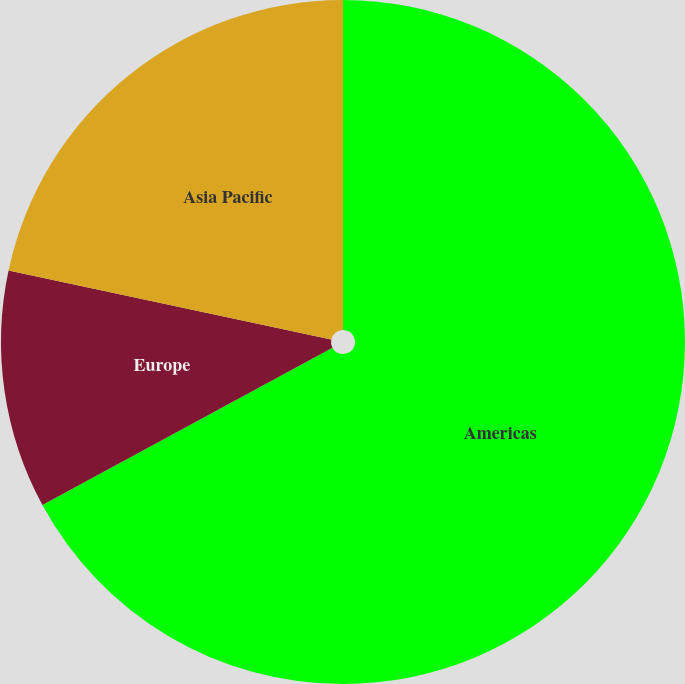<chart> <loc_0><loc_0><loc_500><loc_500><pie_chart><fcel>Americas<fcel>Europe<fcel>Asia Pacific<nl><fcel>67.09%<fcel>11.26%<fcel>21.65%<nl></chart> 